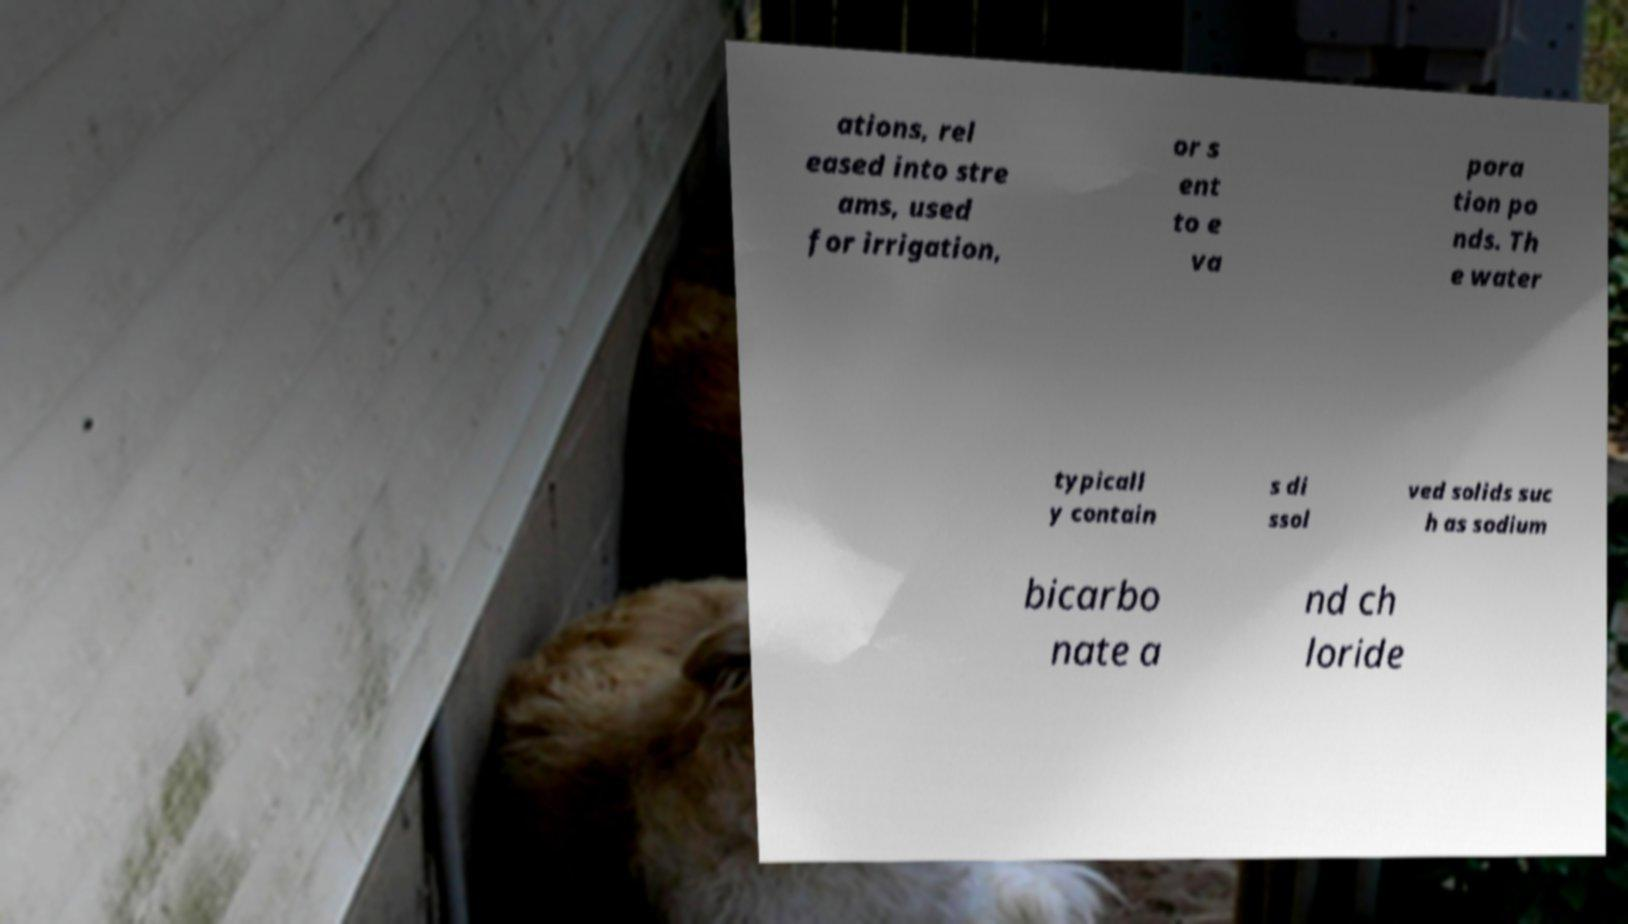Could you assist in decoding the text presented in this image and type it out clearly? ations, rel eased into stre ams, used for irrigation, or s ent to e va pora tion po nds. Th e water typicall y contain s di ssol ved solids suc h as sodium bicarbo nate a nd ch loride 